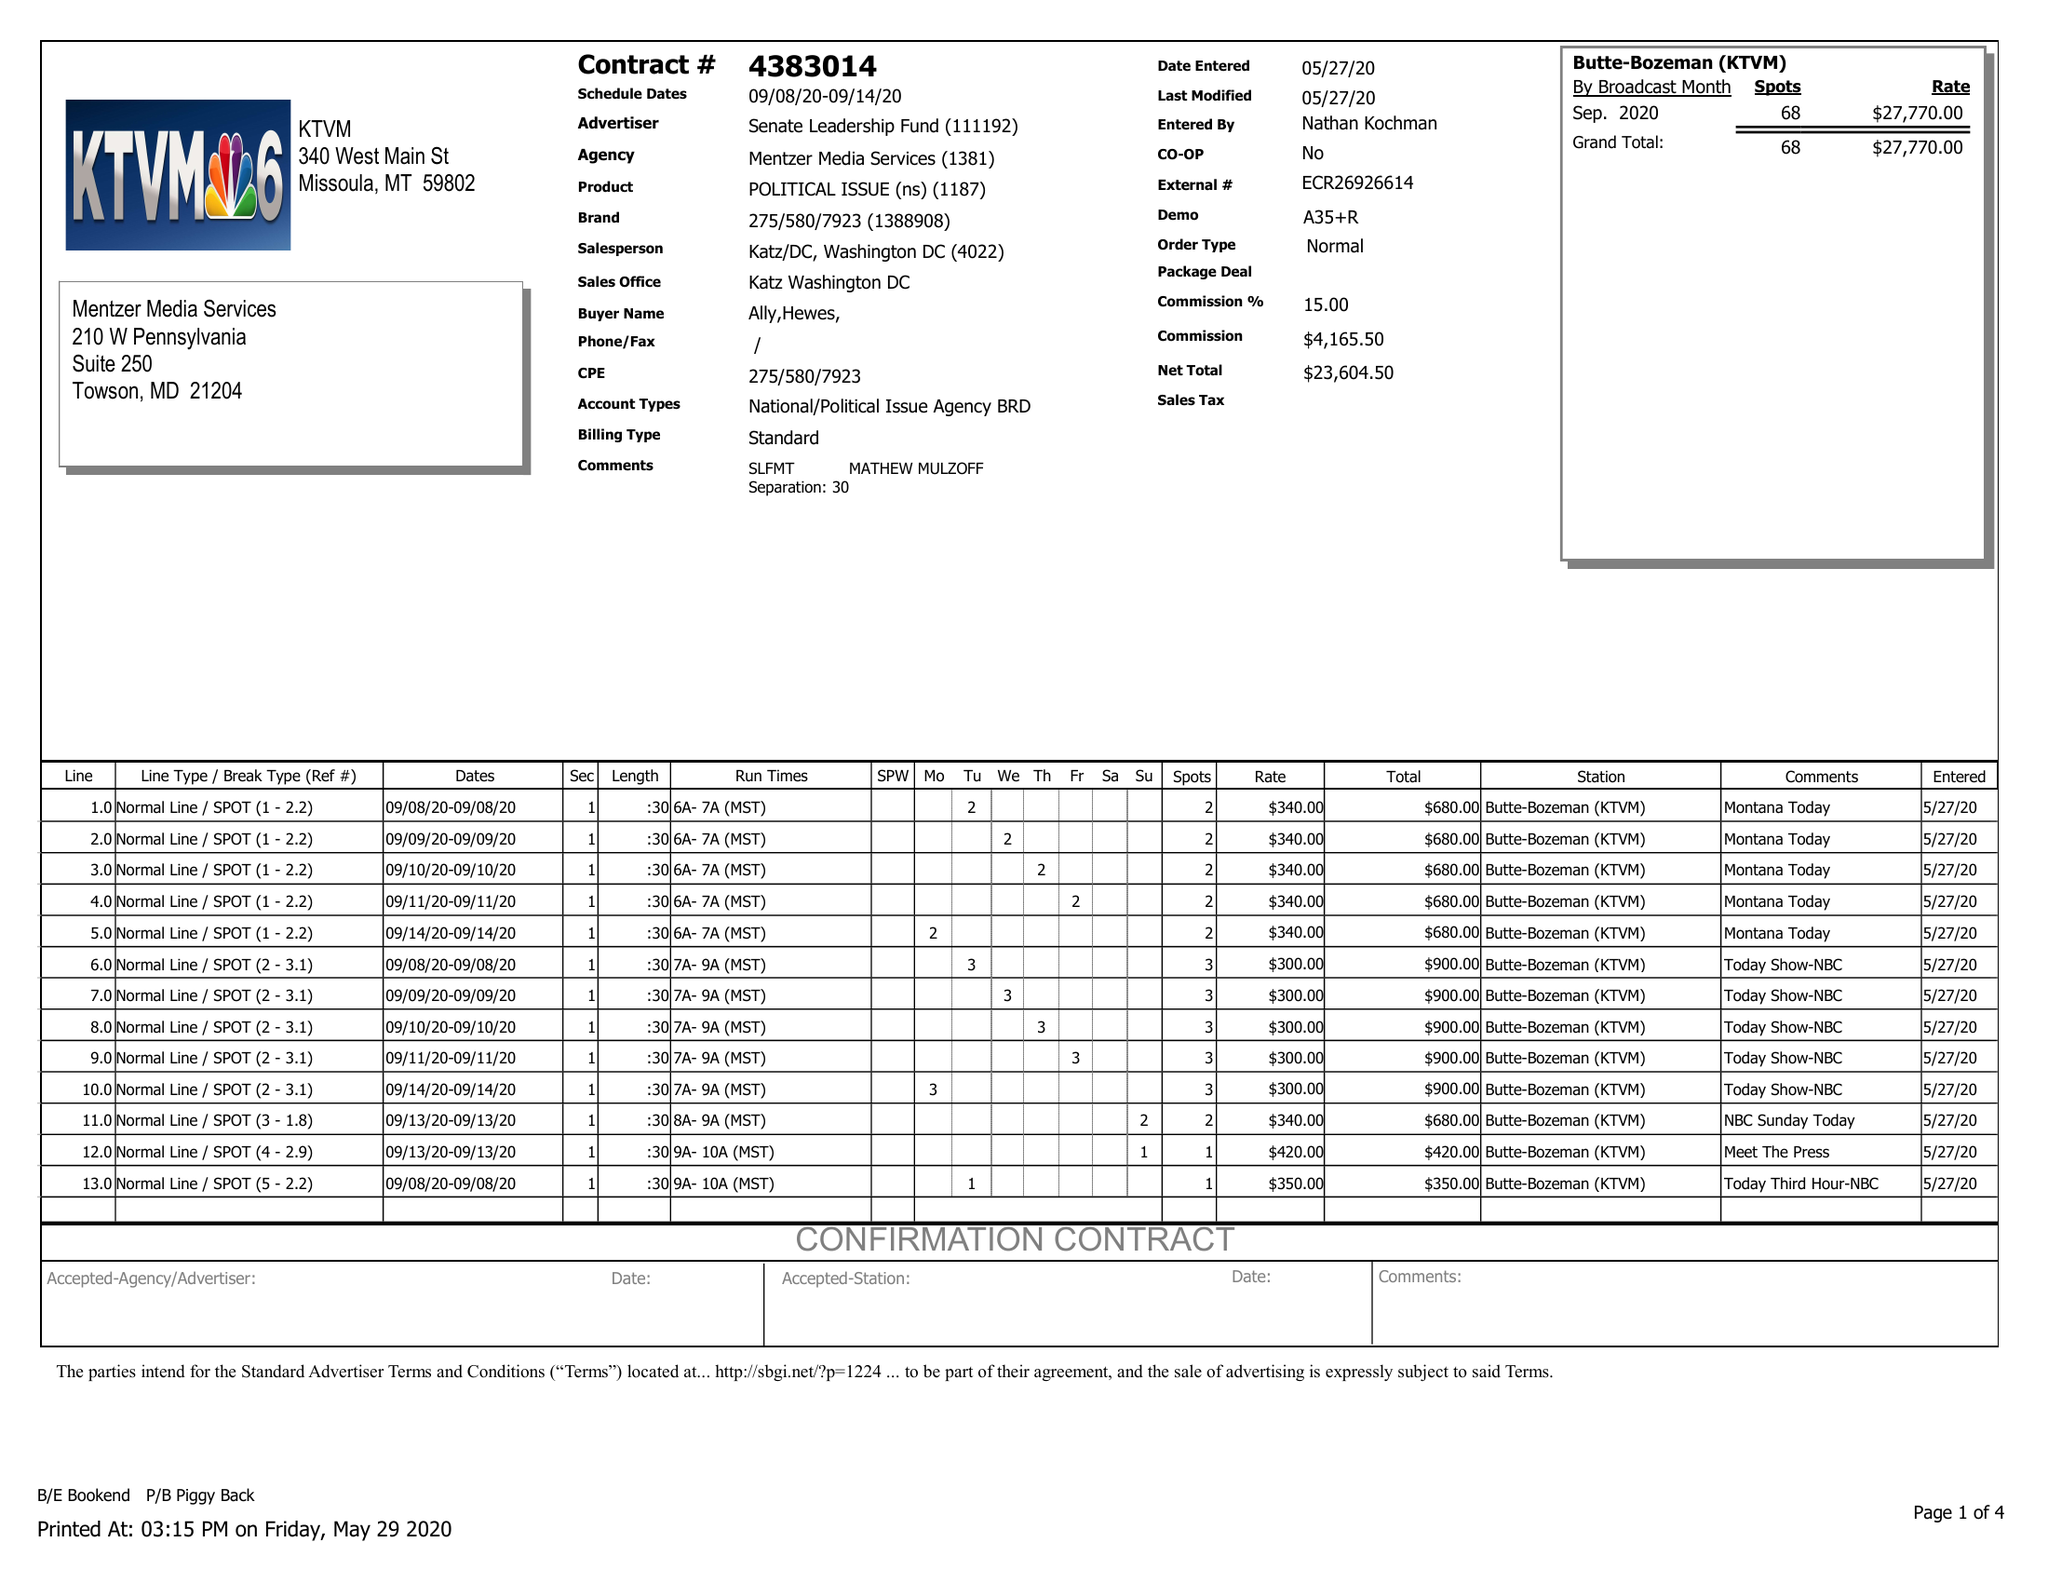What is the value for the advertiser?
Answer the question using a single word or phrase. SENATE LEADERSHIP FUND 